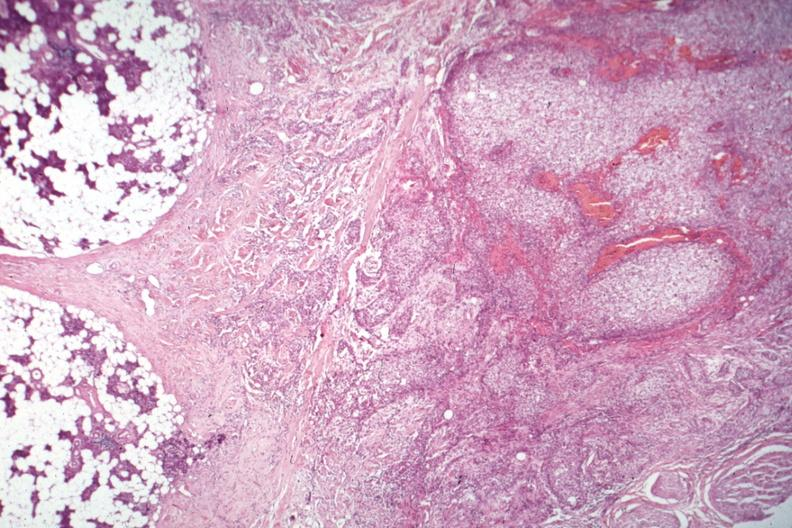what is present?
Answer the question using a single word or phrase. Endocrine 